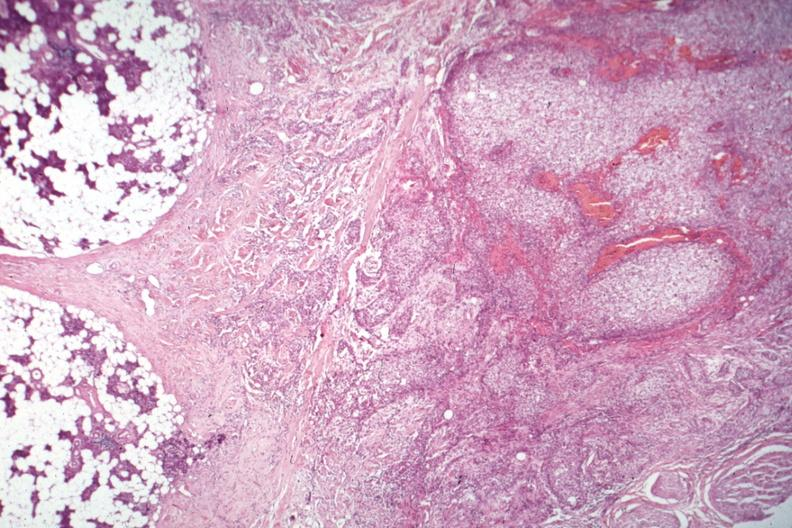what is present?
Answer the question using a single word or phrase. Endocrine 